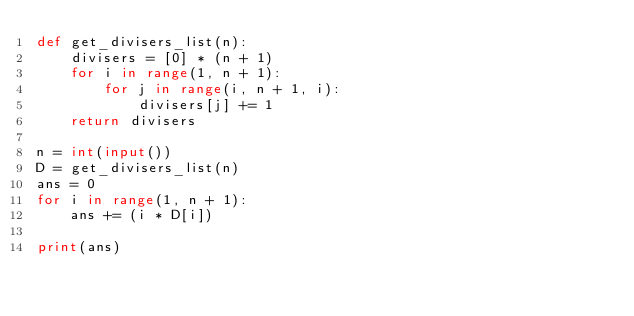<code> <loc_0><loc_0><loc_500><loc_500><_Python_>def get_divisers_list(n):
    divisers = [0] * (n + 1)
    for i in range(1, n + 1):
        for j in range(i, n + 1, i):
            divisers[j] += 1
    return divisers

n = int(input())
D = get_divisers_list(n)
ans = 0
for i in range(1, n + 1):
    ans += (i * D[i])

print(ans)</code> 